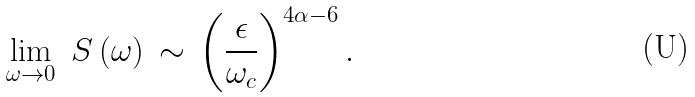Convert formula to latex. <formula><loc_0><loc_0><loc_500><loc_500>\lim _ { \omega \to 0 } \ S \left ( \omega \right ) \, \sim \, \left ( \frac { \epsilon } { \omega _ { c } } \right ) ^ { 4 \alpha - 6 } .</formula> 